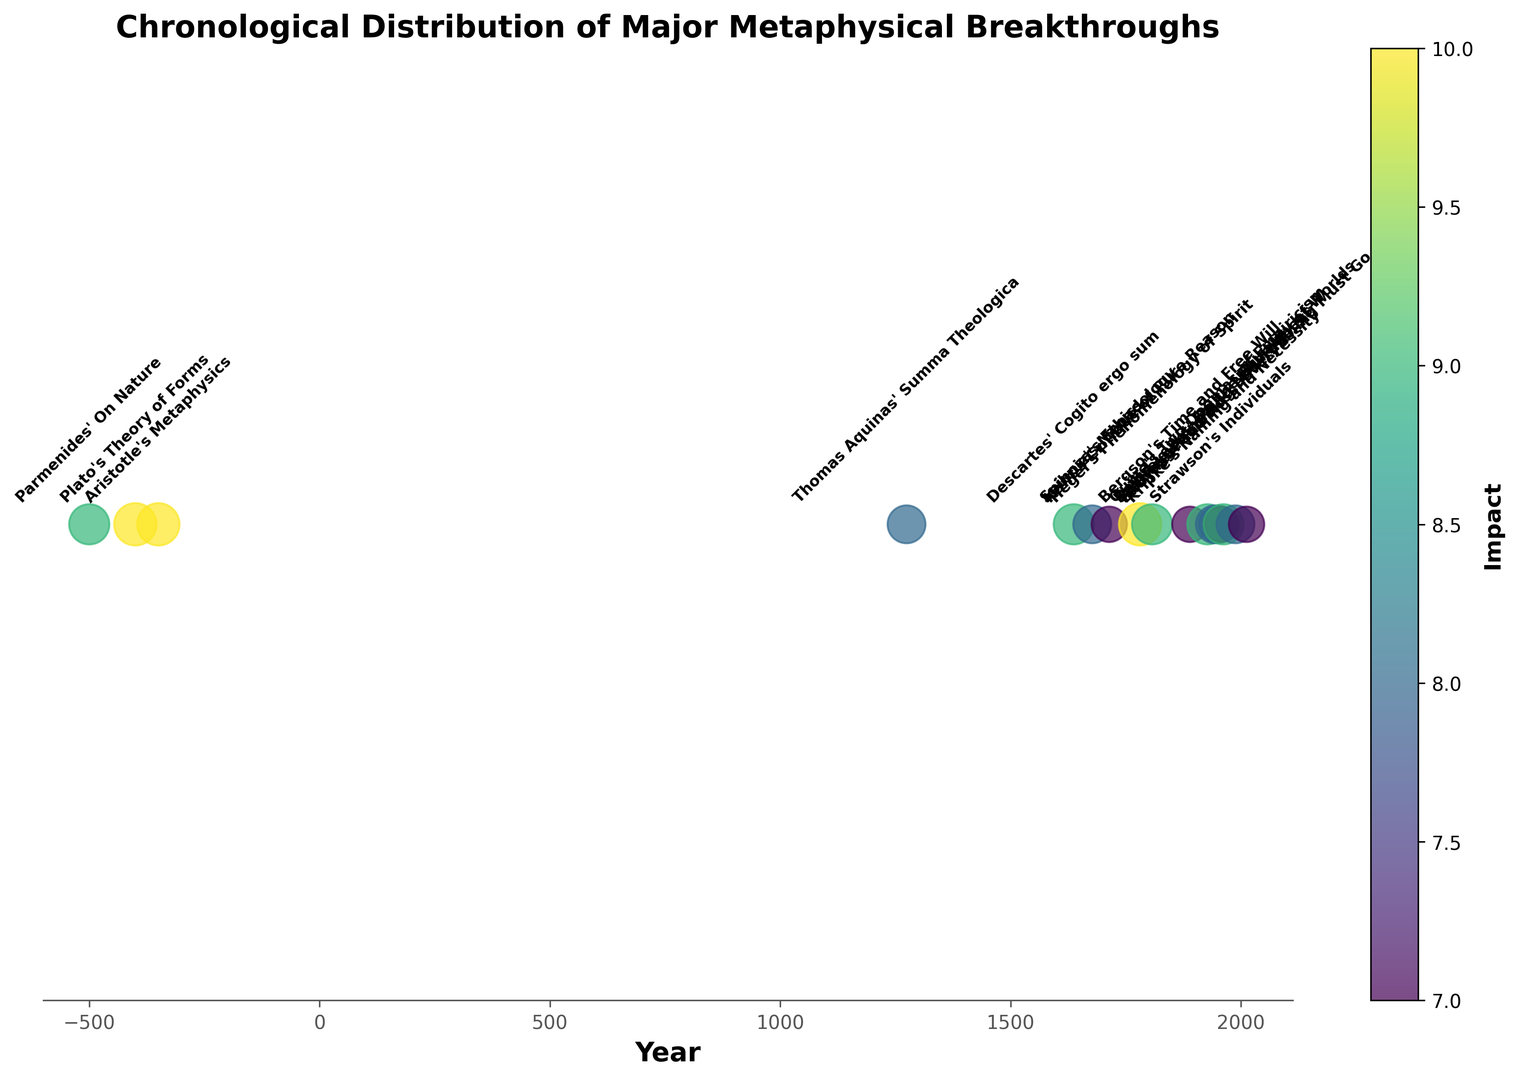what are the two events with the highest impact ratings? Refer to the scatter plot and look for the largest circles as they represent the highest impact ratings. "Plato's Theory of Forms" in -400 and "Aristotle's Metaphysics" in -350 both have the highest impact ratings of 10.
Answer: Plato's Theory of Forms and Aristotle's Metaphysics Is there an observable pattern in the chronological distribution of major metaphysical breakthroughs? Look at the distribution of events across the timeline. Notice that there are clusters of significant breakthroughs in certain historical periods (ancient times, the Enlightenment, and the 20th century), suggesting periods of heightened metaphysical activity.
Answer: Yes, there are clusters in ancient, Enlightenment, and 20th century What was the impact of Thomas Aquinas' Summa Theologica on metaphysical breakthroughs? Identify the position of Thomas Aquinas' Summa Theologica in the timeline and refer to its impact size and color. The Summa Theologica, marked in 1274, has an impact rating of 8, indicating substantial but not the highest influence.
Answer: 8 Which event has the lowest impact rating, and what is its value? Look for the smallest circle represented on the plot and note its corresponding event and impact rating. "Leibniz's Monadology" in 1714 has the lowest impact on the plot with a rating of 7.
Answer: Leibniz's Monadology, 7 Compare the impacts of major metaphysical breakthroughs in the 20th century based on the given plot. Observe the events marked in the 20th century and compare their impact sizes and colors. Significant 20th-century events are "Heidegger's Being and Time" (1927) with an impact of 9, "Sartre's Being and Nothingness" (1943) with an impact of 8, "Quine's Two Dogmas of Empiricism" (1950) with an impact of 8, "Strawson's Individuals" (1957) with an impact of 7, "Kripke's Naming and Necessity" (1962) with an impact of 9, and "David Lewis' On the Plurality of Worlds" (1988) with an impact of 8.
Answer: Heidegger's Being and Time (9), Sartre's Being and Nothingness (8), Quine's Two Dogmas of Empiricism (8), Strawson's Individuals (7), Kripke's Naming and Necessity (9), David Lewis' On the Plurality of Worlds (8) How long is the span between Aristotle's Metaphysics and Kant's Critique of Pure Reason, and what is the difference in their impact ratings? Calculate the difference between the years of these two events and compare their impact ratings. Aristotle's Metaphysics was in -350, and Kant's Critique of Pure Reason in 1781. The span is 1781 - (-350) = 2131 years. Both have an impact rating of 10, so the difference is 0.
Answer: 2131 years, 0 